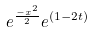Convert formula to latex. <formula><loc_0><loc_0><loc_500><loc_500>e ^ { \frac { - x ^ { 2 } } { 2 } } e ^ { ( 1 - 2 t ) }</formula> 